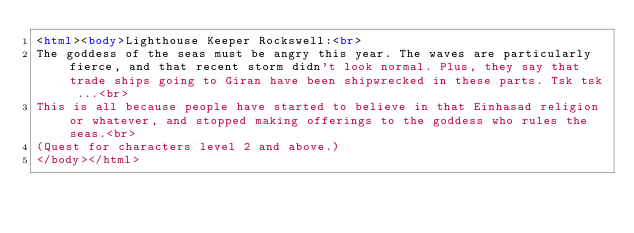Convert code to text. <code><loc_0><loc_0><loc_500><loc_500><_HTML_><html><body>Lighthouse Keeper Rockswell:<br>
The goddess of the seas must be angry this year. The waves are particularly fierce, and that recent storm didn't look normal. Plus, they say that trade ships going to Giran have been shipwrecked in these parts. Tsk tsk ...<br>
This is all because people have started to believe in that Einhasad religion or whatever, and stopped making offerings to the goddess who rules the seas.<br>
(Quest for characters level 2 and above.)
</body></html></code> 